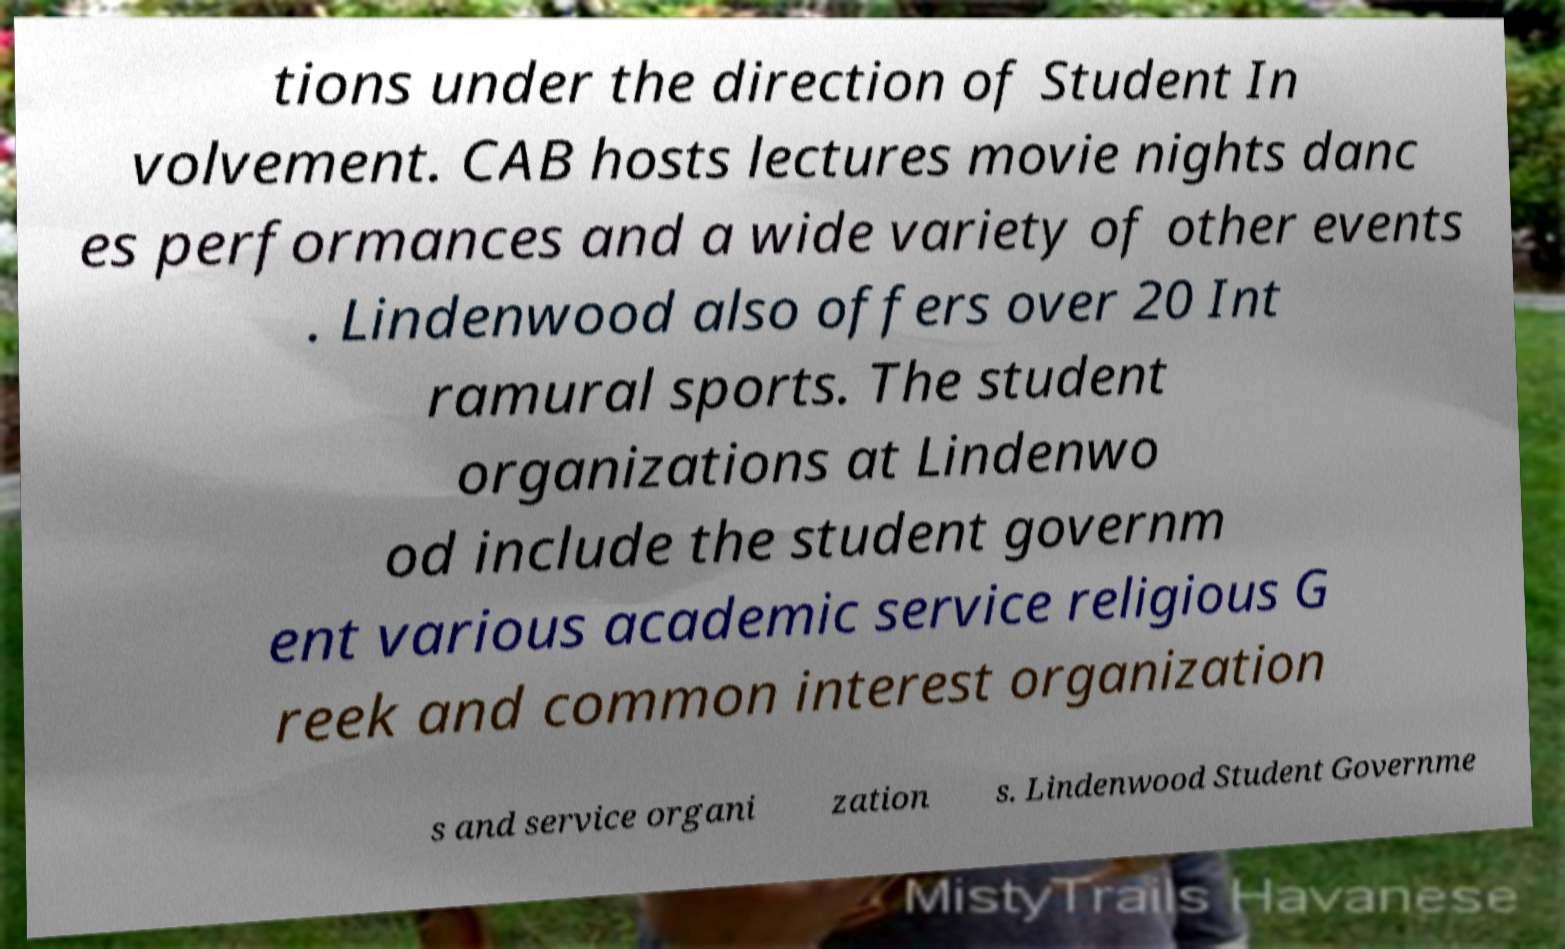I need the written content from this picture converted into text. Can you do that? tions under the direction of Student In volvement. CAB hosts lectures movie nights danc es performances and a wide variety of other events . Lindenwood also offers over 20 Int ramural sports. The student organizations at Lindenwo od include the student governm ent various academic service religious G reek and common interest organization s and service organi zation s. Lindenwood Student Governme 